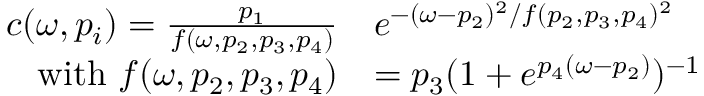<formula> <loc_0><loc_0><loc_500><loc_500>\begin{array} { r l } { c ( \omega , p _ { i } ) = \frac { p _ { 1 } } { f ( \omega , p _ { 2 } , p _ { 3 } , p _ { 4 } ) } } & { e ^ { - ( \omega - p _ { 2 } ) ^ { 2 } / f ( p _ { 2 } , p _ { 3 } , p _ { 4 } ) ^ { 2 } } } \\ { w i t h f ( \omega , p _ { 2 } , p _ { 3 } , p _ { 4 } ) } & { = p _ { 3 } ( 1 + e ^ { p _ { 4 } ( \omega - p _ { 2 } ) } ) ^ { - 1 } } \end{array}</formula> 